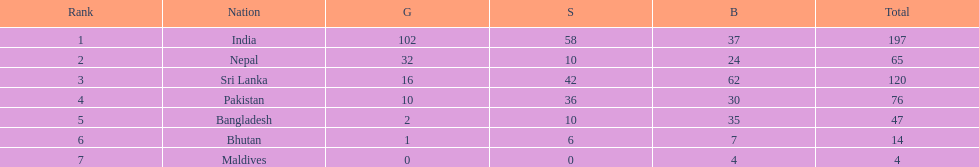Which nation has earned the least amount of gold medals? Maldives. 